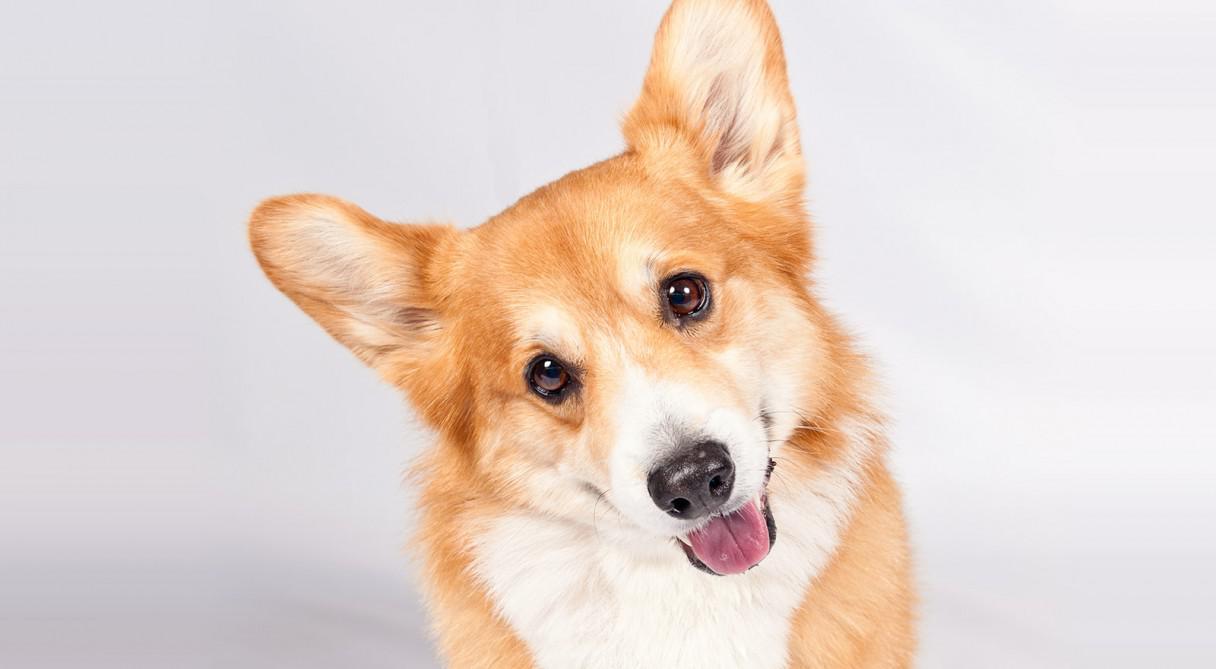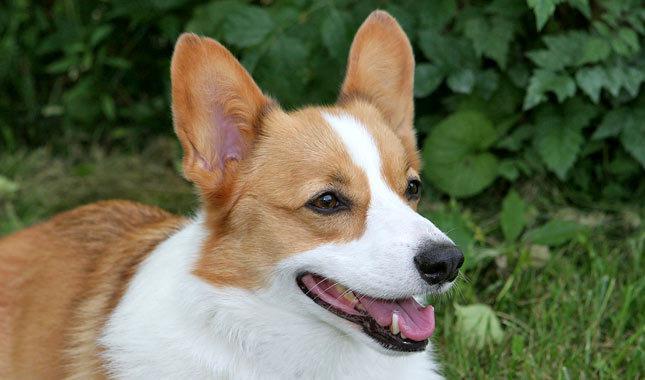The first image is the image on the left, the second image is the image on the right. Considering the images on both sides, is "One of the images shows a corgi sitting on the ground outside with its entire body visible." valid? Answer yes or no. No. 